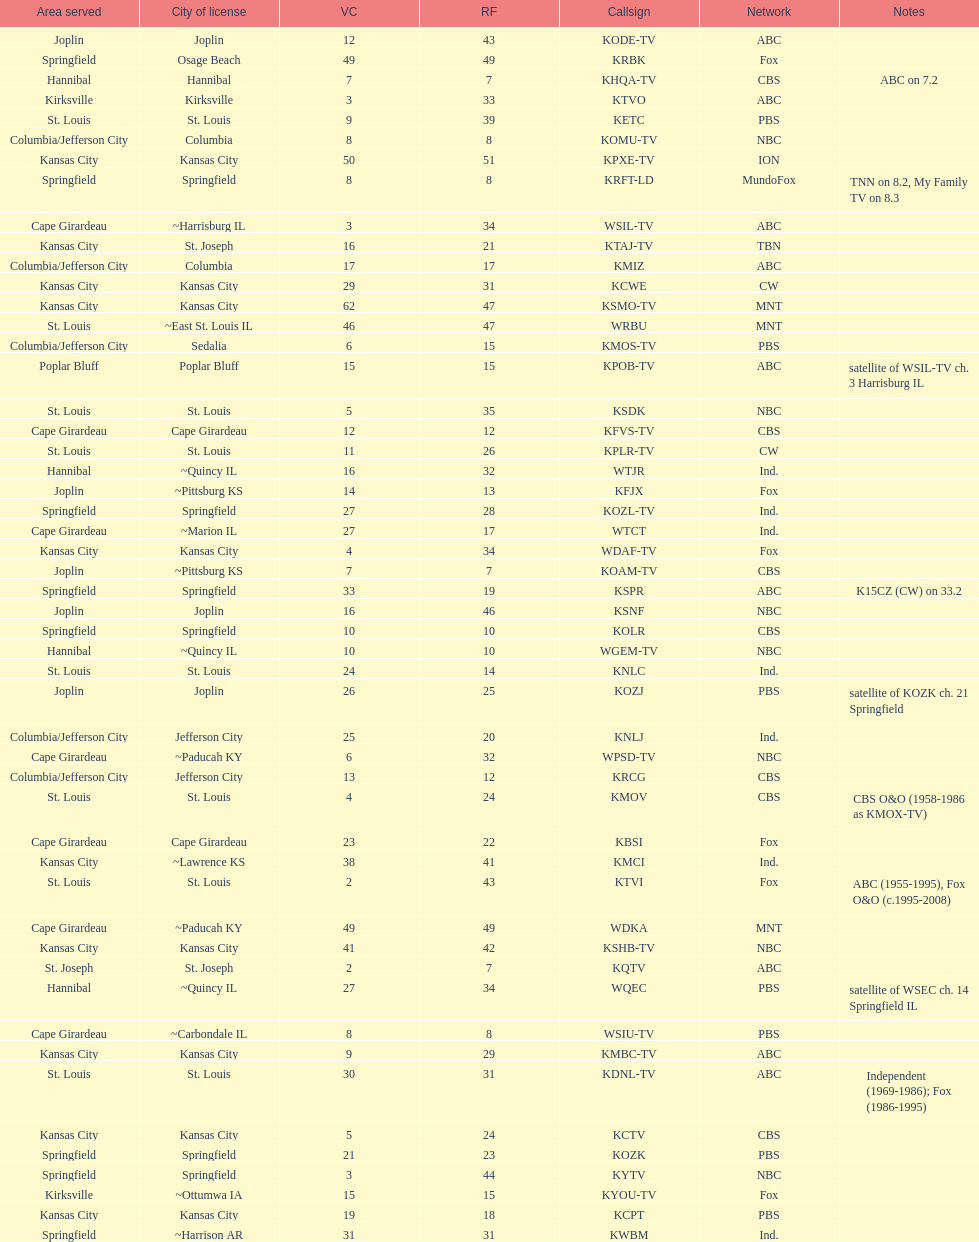What is the total number of cbs stations? 7. 